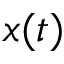<formula> <loc_0><loc_0><loc_500><loc_500>x ( t )</formula> 